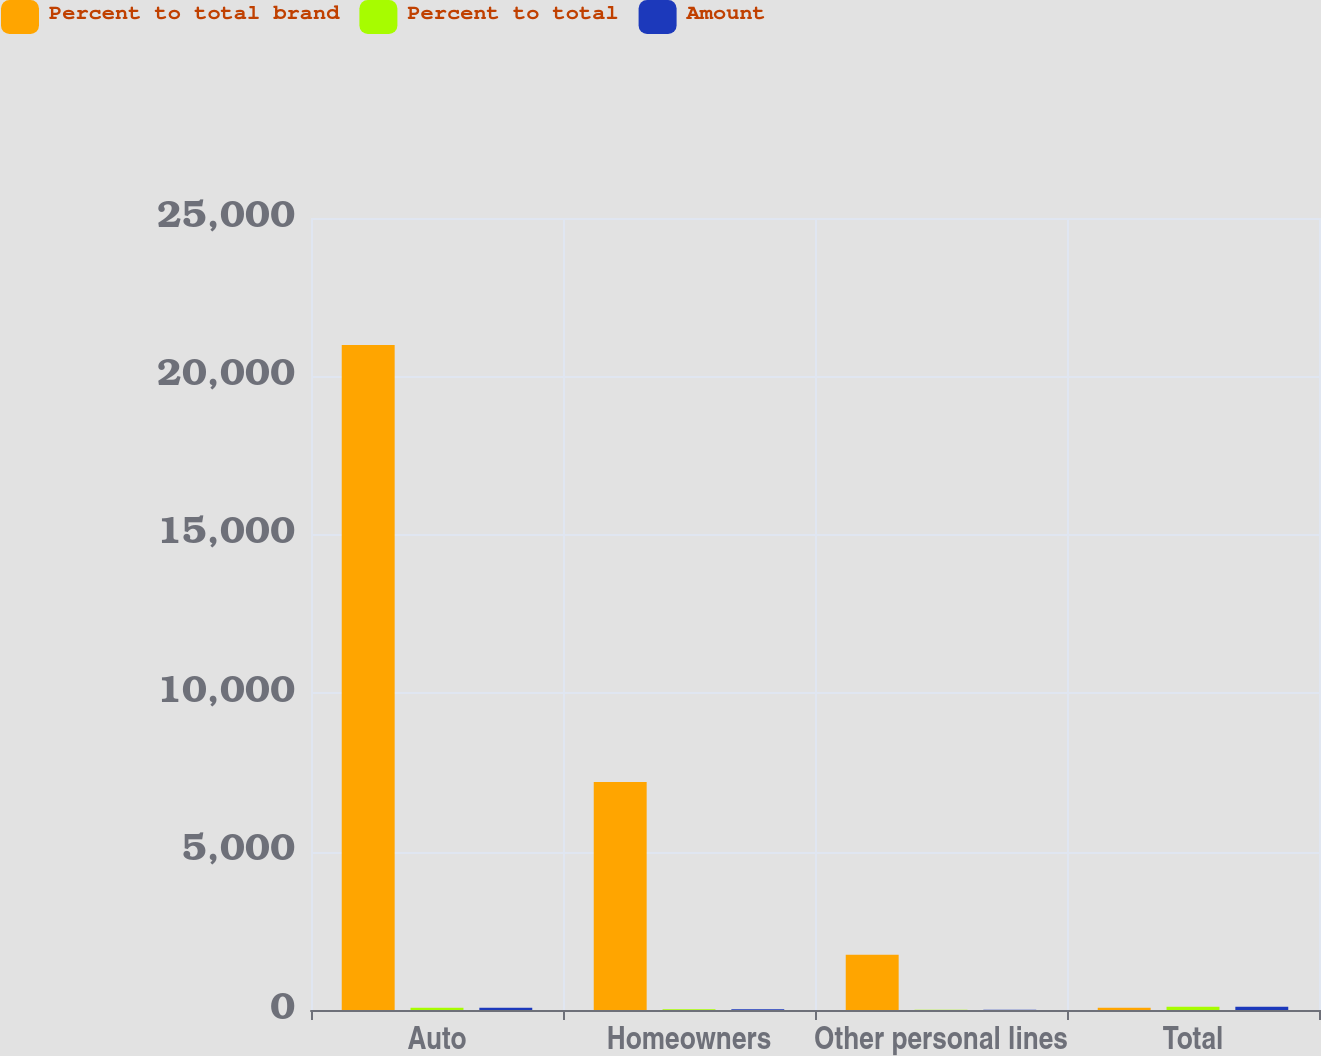<chart> <loc_0><loc_0><loc_500><loc_500><stacked_bar_chart><ecel><fcel>Auto<fcel>Homeowners<fcel>Other personal lines<fcel>Total<nl><fcel>Percent to total brand<fcel>20991<fcel>7199<fcel>1742<fcel>69.6<nl><fcel>Percent to total<fcel>68.6<fcel>23.5<fcel>5.7<fcel>100<nl><fcel>Amount<fcel>69.6<fcel>22.9<fcel>5.5<fcel>100<nl></chart> 